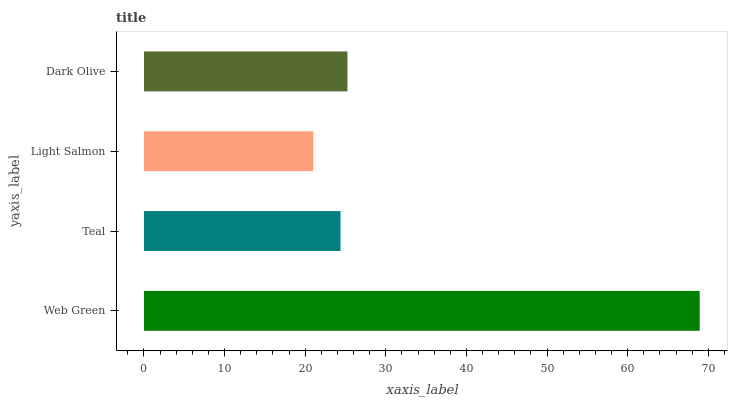Is Light Salmon the minimum?
Answer yes or no. Yes. Is Web Green the maximum?
Answer yes or no. Yes. Is Teal the minimum?
Answer yes or no. No. Is Teal the maximum?
Answer yes or no. No. Is Web Green greater than Teal?
Answer yes or no. Yes. Is Teal less than Web Green?
Answer yes or no. Yes. Is Teal greater than Web Green?
Answer yes or no. No. Is Web Green less than Teal?
Answer yes or no. No. Is Dark Olive the high median?
Answer yes or no. Yes. Is Teal the low median?
Answer yes or no. Yes. Is Teal the high median?
Answer yes or no. No. Is Web Green the low median?
Answer yes or no. No. 